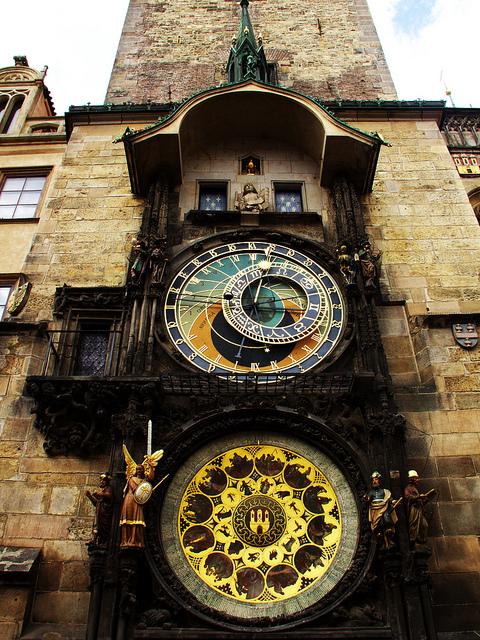Where is this clock located?
Answer briefly. On building. How many 'guards' are next to the lower circle?
Short answer required. 3. What are the sculptures of?
Be succinct. Clocks. What is the time?
Answer briefly. 3:45. 